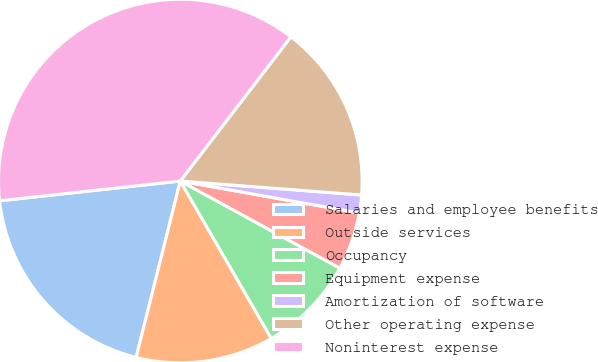<chart> <loc_0><loc_0><loc_500><loc_500><pie_chart><fcel>Salaries and employee benefits<fcel>Outside services<fcel>Occupancy<fcel>Equipment expense<fcel>Amortization of software<fcel>Other operating expense<fcel>Noninterest expense<nl><fcel>19.36%<fcel>12.25%<fcel>8.7%<fcel>5.14%<fcel>1.59%<fcel>15.81%<fcel>37.14%<nl></chart> 